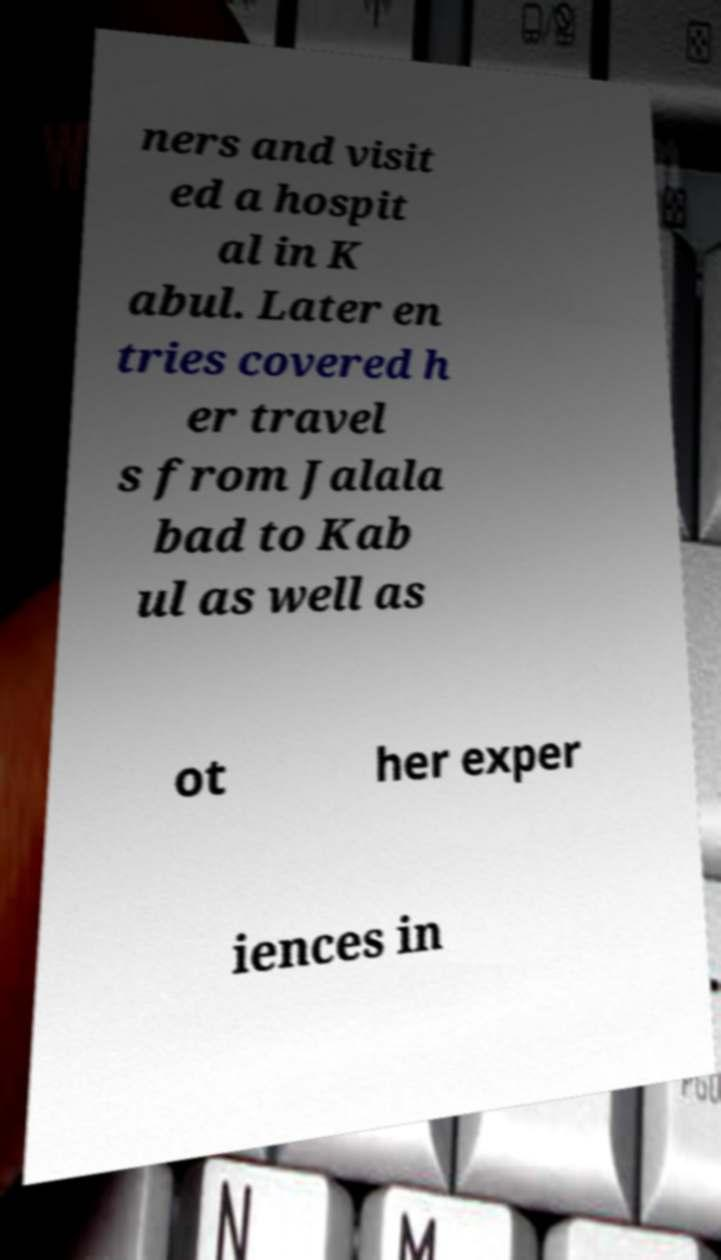Please identify and transcribe the text found in this image. ners and visit ed a hospit al in K abul. Later en tries covered h er travel s from Jalala bad to Kab ul as well as ot her exper iences in 